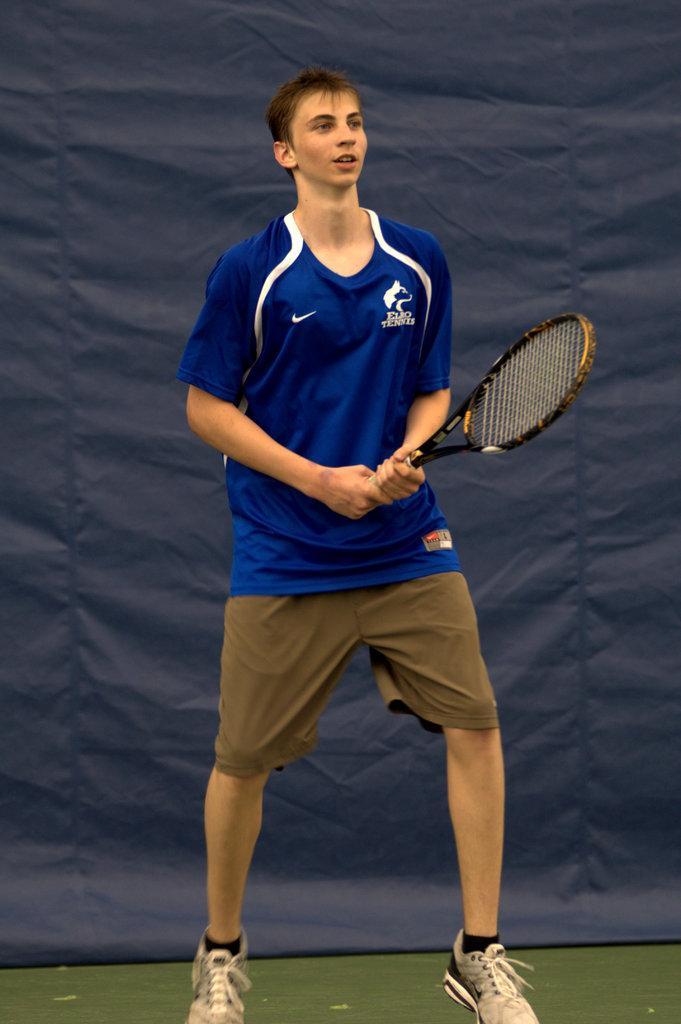How would you summarize this image in a sentence or two? A man is standing holding tennis racket in his hand,behind him there is a banner. 